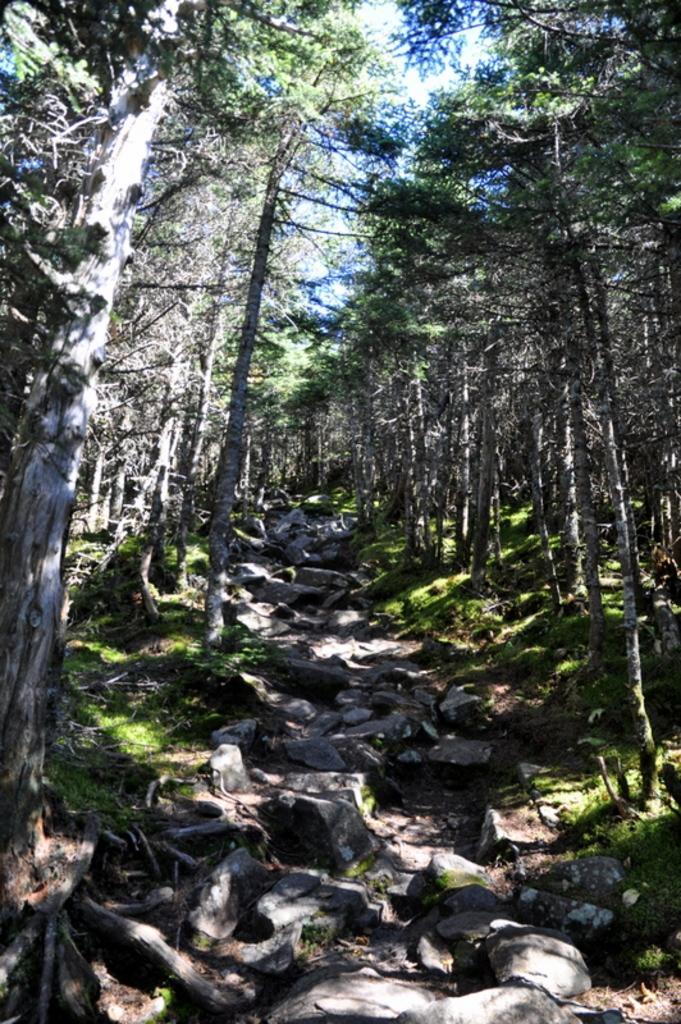Describe this image in one or two sentences. On either side of the picture, we see trees and grass. At the bottom of the picture, we see the way to walk. There are trees in the background. 